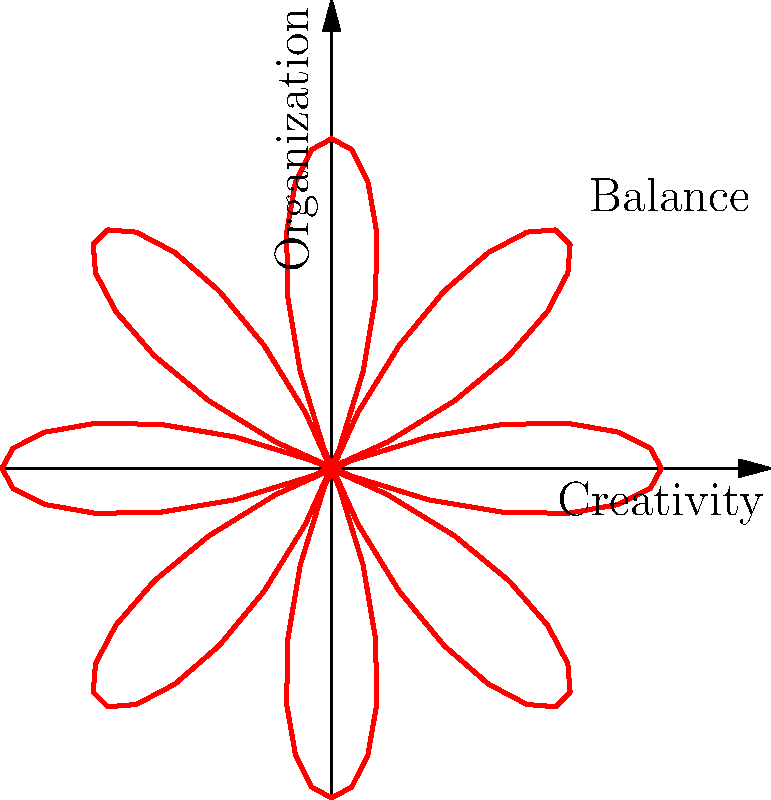In the context of balancing creativity and organization in a home office, a rose curve is graphed using the polar equation $r = 2\cos(4\theta)$. How many petals does this rose curve have, representing the interconnected nature of creativity and organization? To determine the number of petals in a rose curve, we need to follow these steps:

1. Identify the general form of the rose curve equation:
   $r = a \cos(n\theta)$ or $r = a \sin(n\theta)$

2. In our case, the equation is $r = 2\cos(4\theta)$

3. The number of petals in a rose curve is determined by the value of $n$:
   - If $n$ is even, the number of petals is $n$
   - If $n$ is odd, the number of petals is $2n$

4. In our equation, $n = 4$, which is even

5. Therefore, the number of petals is equal to $n = 4$

Each petal in this context represents a point where creativity and organization intersect or complement each other in the home office setting.
Answer: 4 petals 